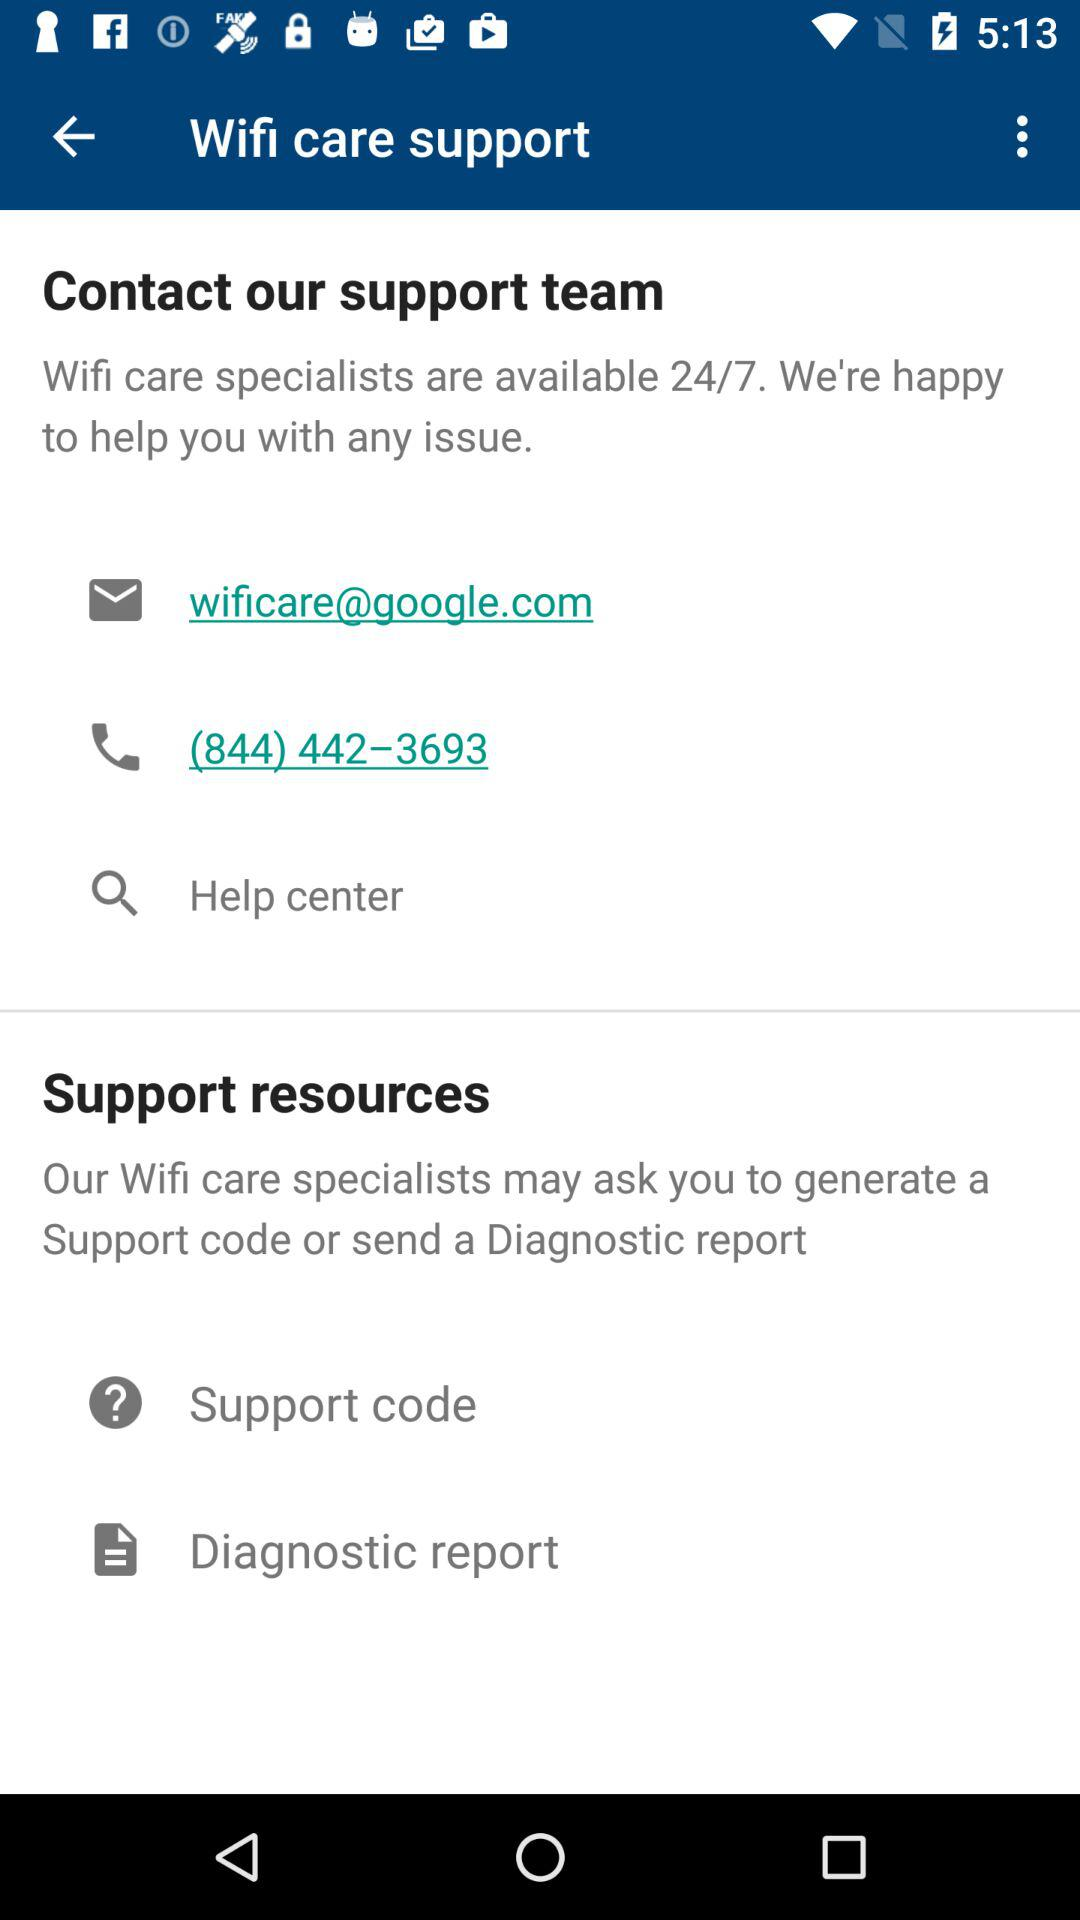How many more contact options are there than support resources that require users to input information?
Answer the question using a single word or phrase. 1 